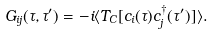<formula> <loc_0><loc_0><loc_500><loc_500>G _ { i j } ( \tau , \tau ^ { \prime } ) = - i \langle T _ { C } [ c _ { i } ( \tau ) c ^ { \dagger } _ { j } ( \tau ^ { \prime } ) ] \rangle .</formula> 